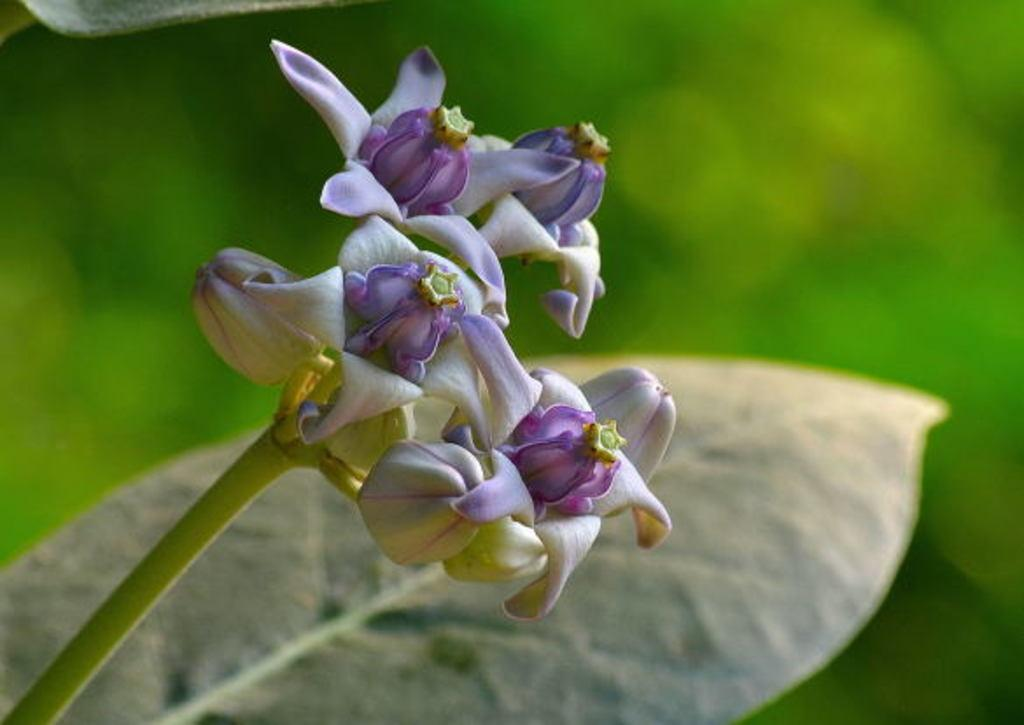What is the main subject in the center of the image? There is a leaf in the center of the image. What other elements can be seen in the image? There are flowers in the image. What colors are the flowers? The flowers are in white and violet color. How does the leaf express its feelings in the image? Leaves do not have feelings, so this question is not applicable to the image. 